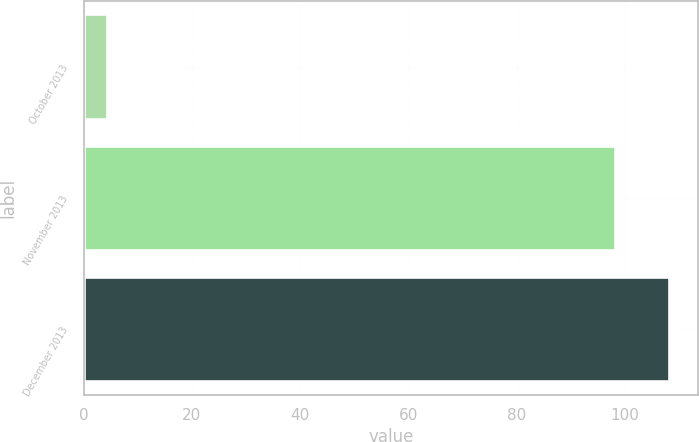Convert chart. <chart><loc_0><loc_0><loc_500><loc_500><bar_chart><fcel>October 2013<fcel>November 2013<fcel>December 2013<nl><fcel>4.39<fcel>98.18<fcel>108.15<nl></chart> 